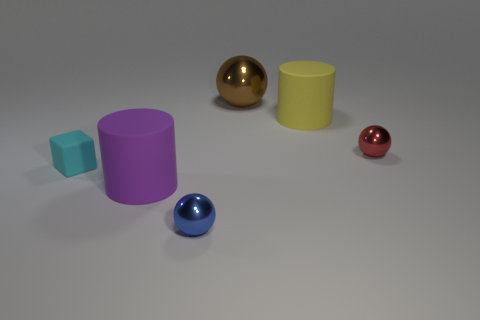Subtract all brown cubes. Subtract all gray balls. How many cubes are left? 1 Add 2 purple shiny objects. How many objects exist? 8 Subtract all cylinders. How many objects are left? 4 Subtract 0 blue cylinders. How many objects are left? 6 Subtract all big gray shiny things. Subtract all small matte blocks. How many objects are left? 5 Add 4 blocks. How many blocks are left? 5 Add 3 purple cylinders. How many purple cylinders exist? 4 